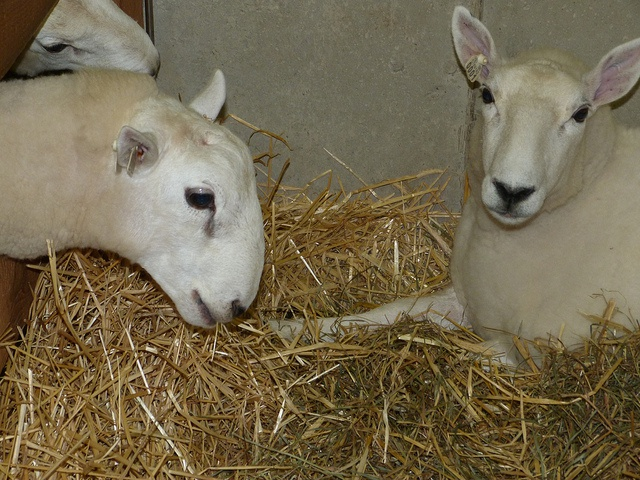Describe the objects in this image and their specific colors. I can see sheep in maroon, gray, and darkgray tones, sheep in maroon, darkgray, and gray tones, and sheep in maroon, darkgray, gray, and black tones in this image. 